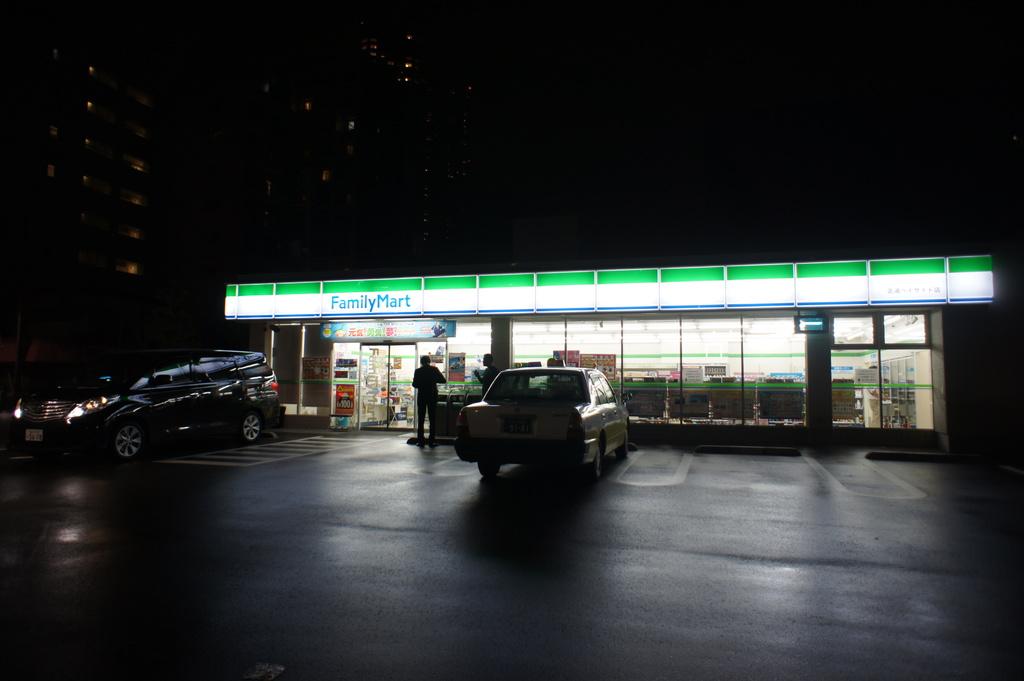What is the name of the store?
Give a very brief answer. Familymart. 